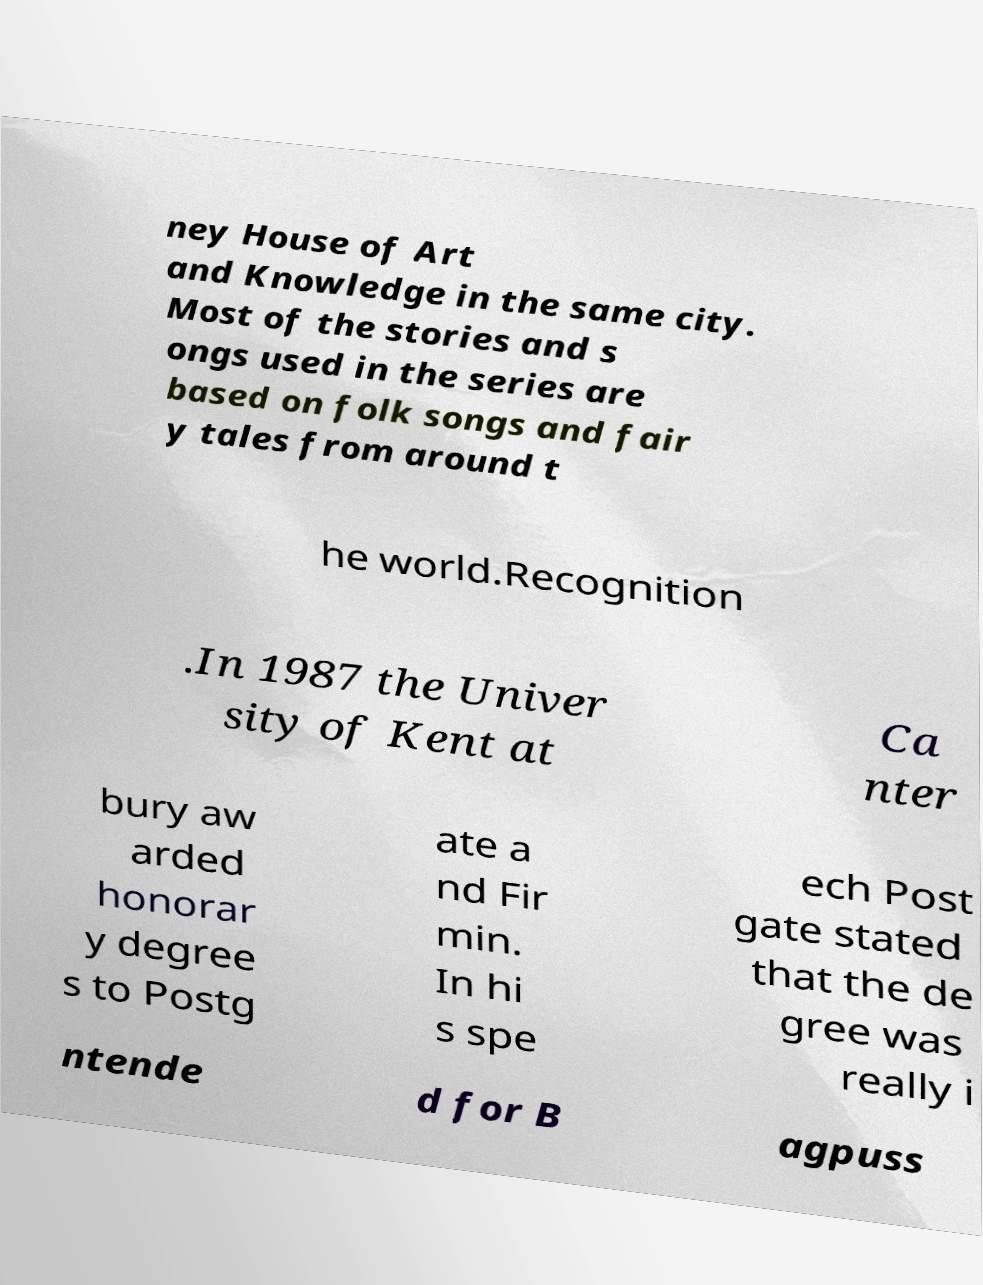Please identify and transcribe the text found in this image. ney House of Art and Knowledge in the same city. Most of the stories and s ongs used in the series are based on folk songs and fair y tales from around t he world.Recognition .In 1987 the Univer sity of Kent at Ca nter bury aw arded honorar y degree s to Postg ate a nd Fir min. In hi s spe ech Post gate stated that the de gree was really i ntende d for B agpuss 